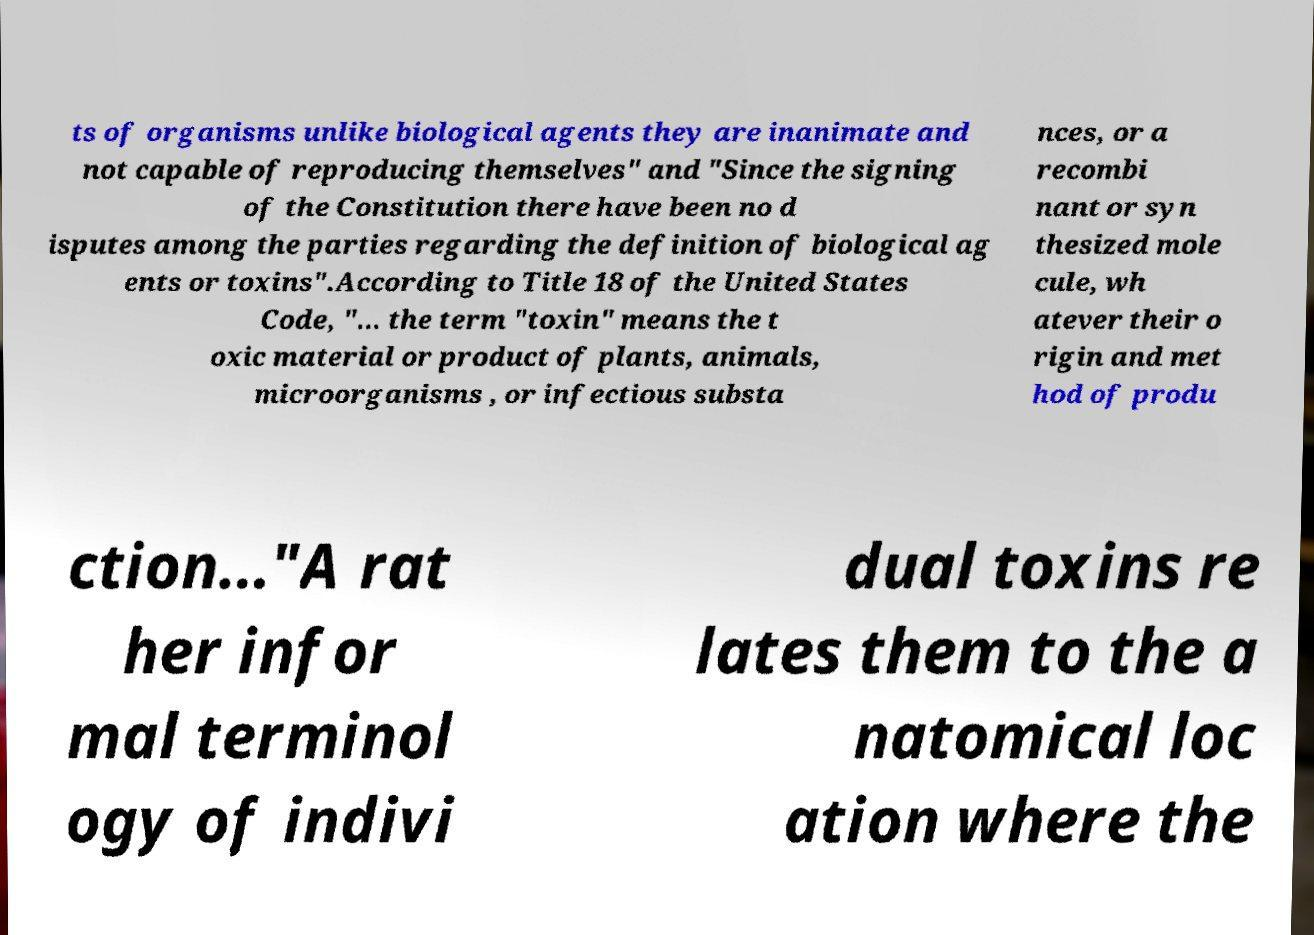Can you accurately transcribe the text from the provided image for me? ts of organisms unlike biological agents they are inanimate and not capable of reproducing themselves" and "Since the signing of the Constitution there have been no d isputes among the parties regarding the definition of biological ag ents or toxins".According to Title 18 of the United States Code, "... the term "toxin" means the t oxic material or product of plants, animals, microorganisms , or infectious substa nces, or a recombi nant or syn thesized mole cule, wh atever their o rigin and met hod of produ ction..."A rat her infor mal terminol ogy of indivi dual toxins re lates them to the a natomical loc ation where the 